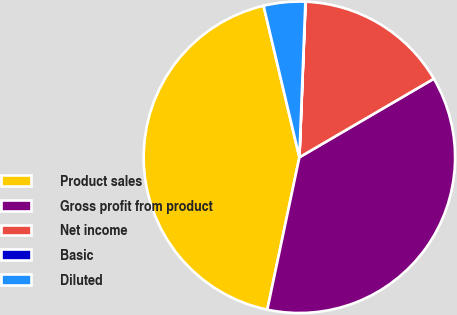<chart> <loc_0><loc_0><loc_500><loc_500><pie_chart><fcel>Product sales<fcel>Gross profit from product<fcel>Net income<fcel>Basic<fcel>Diluted<nl><fcel>43.0%<fcel>36.72%<fcel>15.95%<fcel>0.02%<fcel>4.31%<nl></chart> 